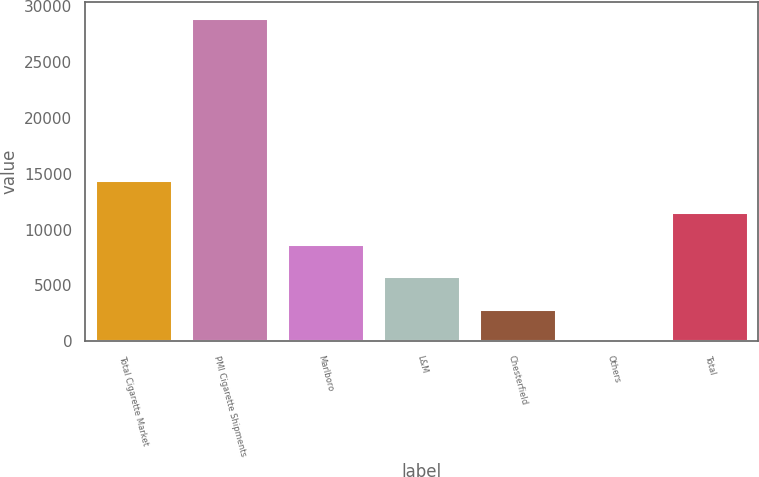Convert chart to OTSL. <chart><loc_0><loc_0><loc_500><loc_500><bar_chart><fcel>Total Cigarette Market<fcel>PMI Cigarette Shipments<fcel>Marlboro<fcel>L&M<fcel>Chesterfield<fcel>Others<fcel>Total<nl><fcel>14475.7<fcel>28950<fcel>8685.98<fcel>5791.12<fcel>2896.26<fcel>1.4<fcel>11580.8<nl></chart> 